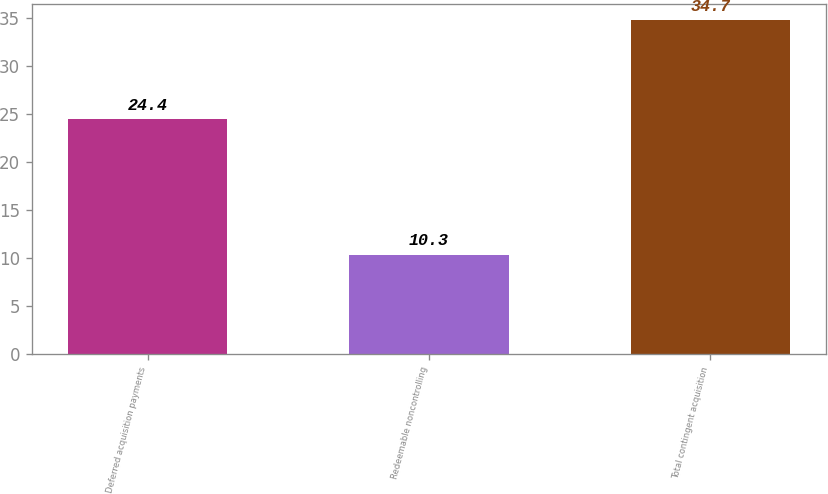Convert chart. <chart><loc_0><loc_0><loc_500><loc_500><bar_chart><fcel>Deferred acquisition payments<fcel>Redeemable noncontrolling<fcel>Total contingent acquisition<nl><fcel>24.4<fcel>10.3<fcel>34.7<nl></chart> 